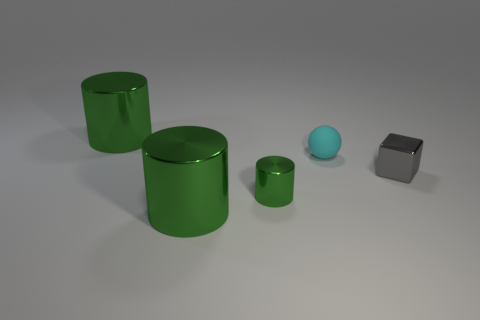What number of other metal cylinders are the same color as the small metallic cylinder?
Keep it short and to the point. 2. What number of things are metal things that are in front of the small gray object or cyan rubber balls?
Your answer should be compact. 3. The metallic cylinder to the right of the large thing that is in front of the tiny object to the left of the cyan rubber object is what color?
Your answer should be compact. Green. The small cylinder that is made of the same material as the small gray thing is what color?
Keep it short and to the point. Green. What number of spheres are made of the same material as the tiny green cylinder?
Make the answer very short. 0. There is a metal block that is in front of the cyan rubber ball; does it have the same size as the tiny cyan rubber thing?
Ensure brevity in your answer.  Yes. There is a metal thing that is the same size as the metallic block; what is its color?
Ensure brevity in your answer.  Green. What number of large green shiny cylinders are behind the cyan ball?
Your answer should be compact. 1. Are any large blue matte cylinders visible?
Make the answer very short. No. There is a green metallic thing that is right of the large green metallic cylinder that is to the right of the green metal cylinder behind the gray metallic cube; what size is it?
Provide a succinct answer. Small. 